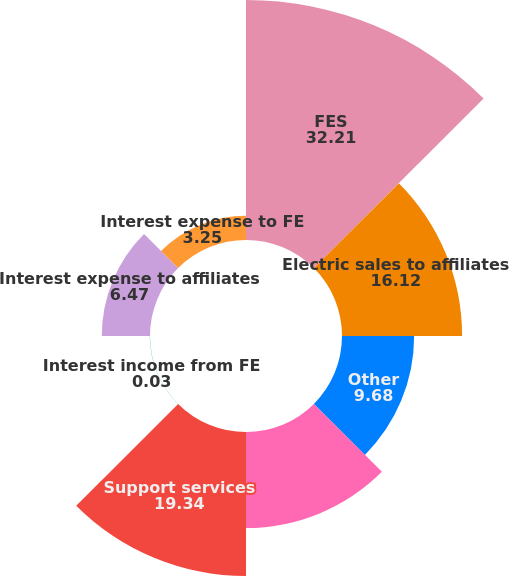Convert chart. <chart><loc_0><loc_0><loc_500><loc_500><pie_chart><fcel>FES<fcel>Electric sales to affiliates<fcel>Other<fcel>Purchased power from<fcel>Support services<fcel>Interest income from FE<fcel>Interest expense to affiliates<fcel>Interest expense to FE<nl><fcel>32.21%<fcel>16.12%<fcel>9.68%<fcel>12.9%<fcel>19.34%<fcel>0.03%<fcel>6.47%<fcel>3.25%<nl></chart> 